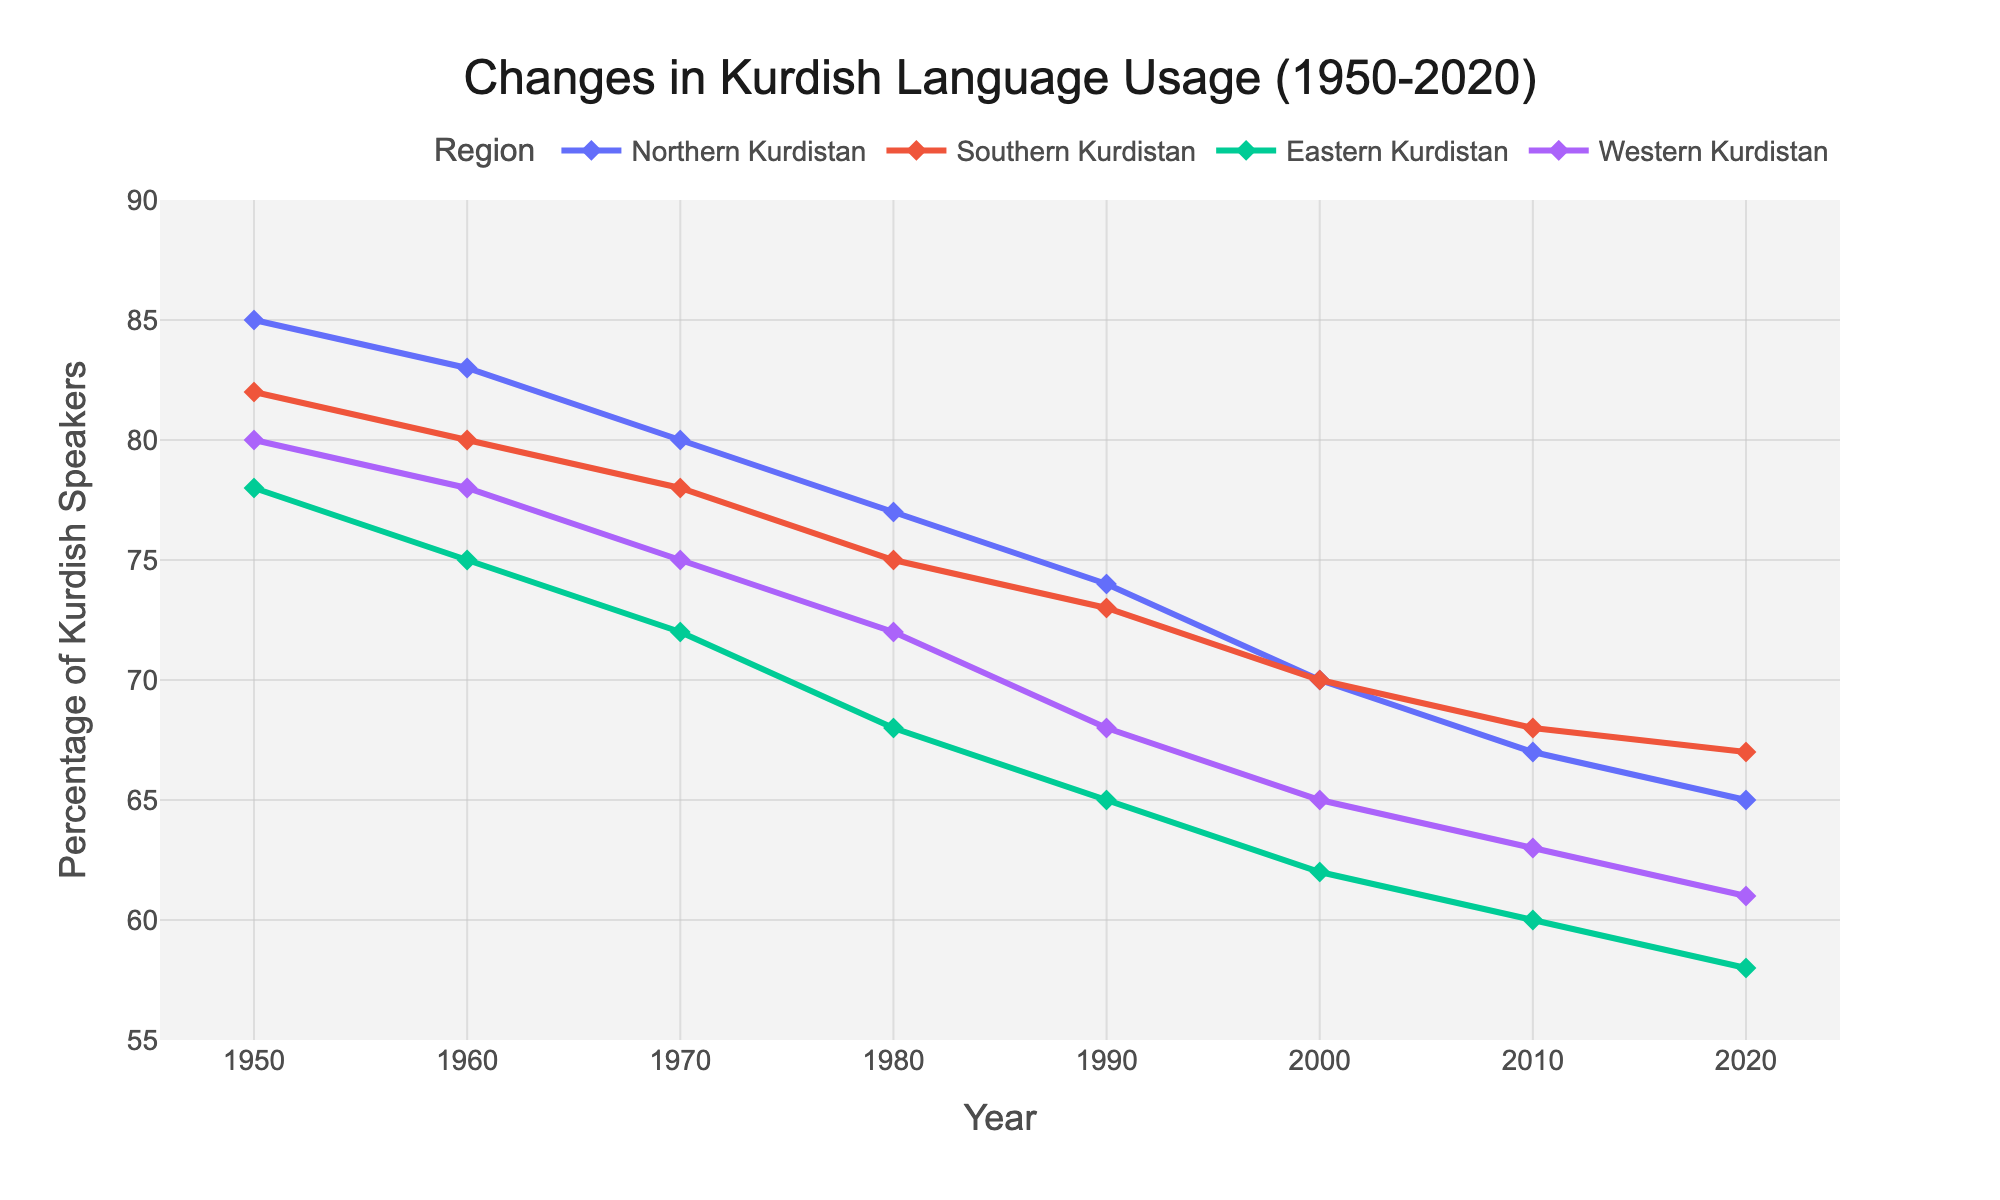What is the percentage difference in Kurdish language usage between Northern and Southern Kurdistan in 1950? In the year 1950, the percentage of Kurdish language usage in Northern Kurdistan is 85%, and in Southern Kurdistan, it is 82%. The percentage difference is calculated as 85% - 82% = 3%.
Answer: 3% How has the percentage of Kurdish speakers in Eastern Kurdistan changed from 1960 to 2020? In 1960, the percentage of Kurdish speakers in Eastern Kurdistan is 75%. In 2020, the percentage is 58%. The change is calculated as 75% - 58% = 17%. Therefore, there was a decrease of 17 percentage points over these years.
Answer: 17% Which region had the smallest decline in Kurdish language usage from 1950 to 2020? To find the smallest decline, we compare the percentage differences for each region between 1950 and 2020: Northern Kurdistan: 85% - 65% = 20% decline, Southern Kurdistan: 82% - 67% = 15% decline, Eastern Kurdistan: 78% - 58% = 20% decline, Western Kurdistan: 80% - 61% = 19% decline. Southern Kurdistan had the smallest decline of 15 percentage points.
Answer: Southern Kurdistan What was the average percentage of Kurdish speakers in Western Kurdistan from 1950 to 2020? The percentages for Western Kurdistan over the years are 80, 78, 75, 72, 68, 65, 63, and 61. The sum is 80 + 78 + 75 + 72 + 68 + 65 + 63 + 61 = 562. There are 8 data points, so the average is 562 / 8 = 70.25%.
Answer: 70.25% Is there a year when Southern and Eastern Kurdistan had the same percentage of Kurdish speakers? By looking at each year: 1950: 82% (Southern) vs. 78% (Eastern), 1960: 80% vs. 75%, 1970: 78% vs. 72%, 1980: 75% vs. 68%, 1990: 73% vs. 65%, 2000: 70% vs. 62%, 2010: 68% vs. 60%, 2020: 67% vs. 58%. There is no year when Southern and Eastern Kurdistan had the same percentage of Kurdish speakers.
Answer: No Between which two consecutive decades did Northern Kurdistan see the largest drop in Kurdish language usage? Calculate the change between each consecutive decade: 1950-1960: 85% - 83% = 2%, 1960-1970: 83% - 80% = 3%, 1970-1980: 80% - 77% = 3%, 1980-1990: 77% - 74% = 3%, 1990-2000: 74% - 70% = 4%, 2000-2010: 70% - 67% = 3%, 2010-2020: 67% - 65% = 2%. The largest drop of 4 percentage points was between 1990 and 2000.
Answer: 1990-2000 Which region had a steady or increasing trend in Kurdish language usage during the decade from 2010 to 2020? Compare the percentages in each region from 2010 to 2020: Northern Kurdistan: 67% to 65% (decrease), Southern Kurdistan: 68% to 67% (decrease), Eastern Kurdistan: 60% to 58% (decrease), Western Kurdistan: 63% to 61% (decrease). None of the regions had a steady or increasing trend in percentage usage during that decade.
Answer: None 